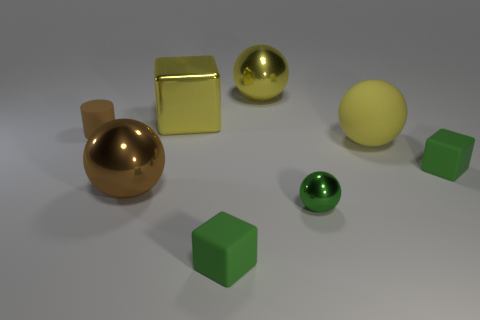Subtract all large brown spheres. How many spheres are left? 3 Subtract all brown balls. How many balls are left? 3 Add 2 yellow metal things. How many objects exist? 10 Subtract all cylinders. How many objects are left? 7 Subtract 1 cylinders. How many cylinders are left? 0 Subtract all blue blocks. Subtract all blue balls. How many blocks are left? 3 Subtract all purple cylinders. How many brown balls are left? 1 Subtract all green spheres. Subtract all large red rubber cylinders. How many objects are left? 7 Add 4 tiny brown cylinders. How many tiny brown cylinders are left? 5 Add 1 yellow metallic things. How many yellow metallic things exist? 3 